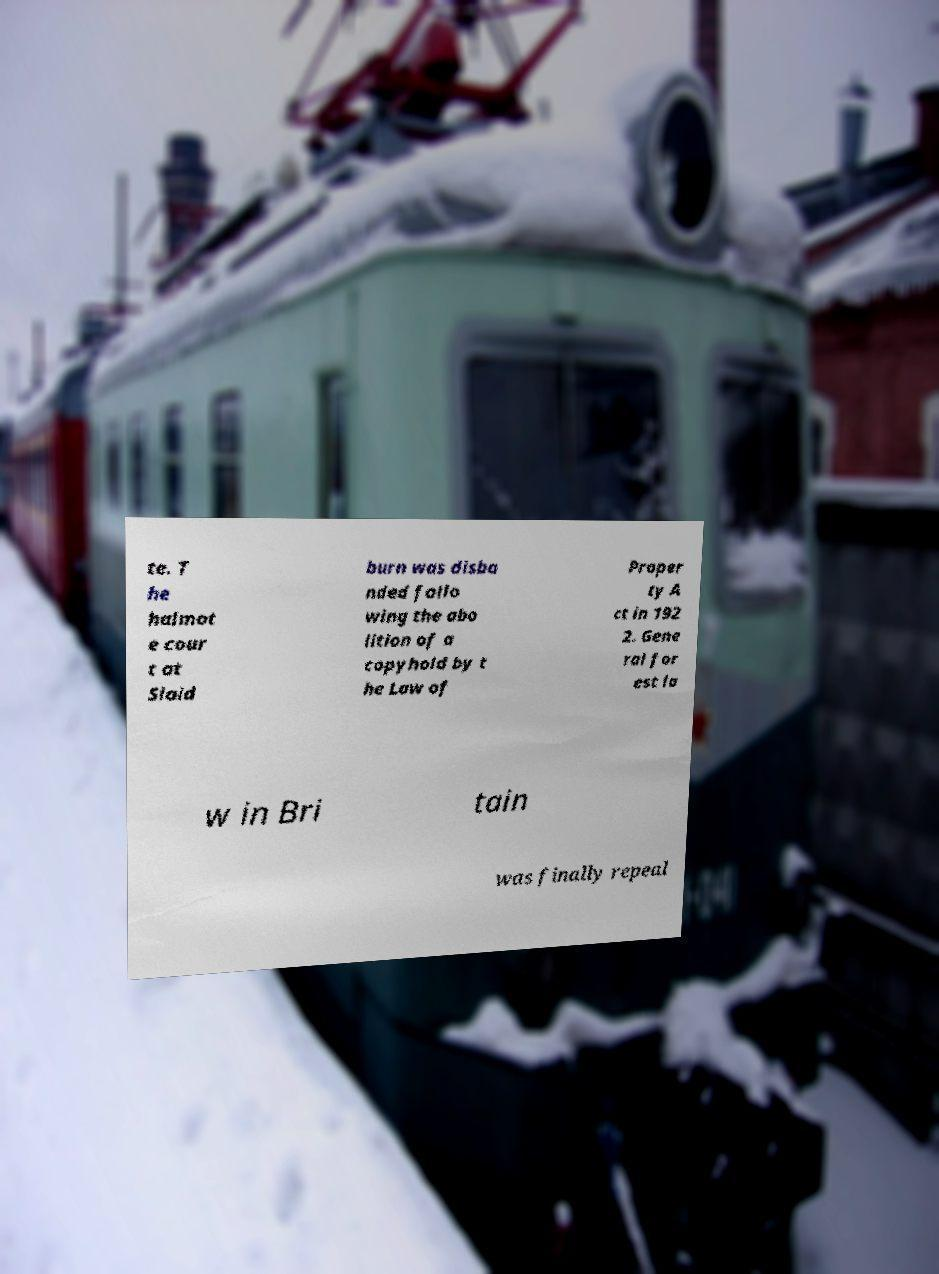For documentation purposes, I need the text within this image transcribed. Could you provide that? te. T he halmot e cour t at Slaid burn was disba nded follo wing the abo lition of a copyhold by t he Law of Proper ty A ct in 192 2. Gene ral for est la w in Bri tain was finally repeal 